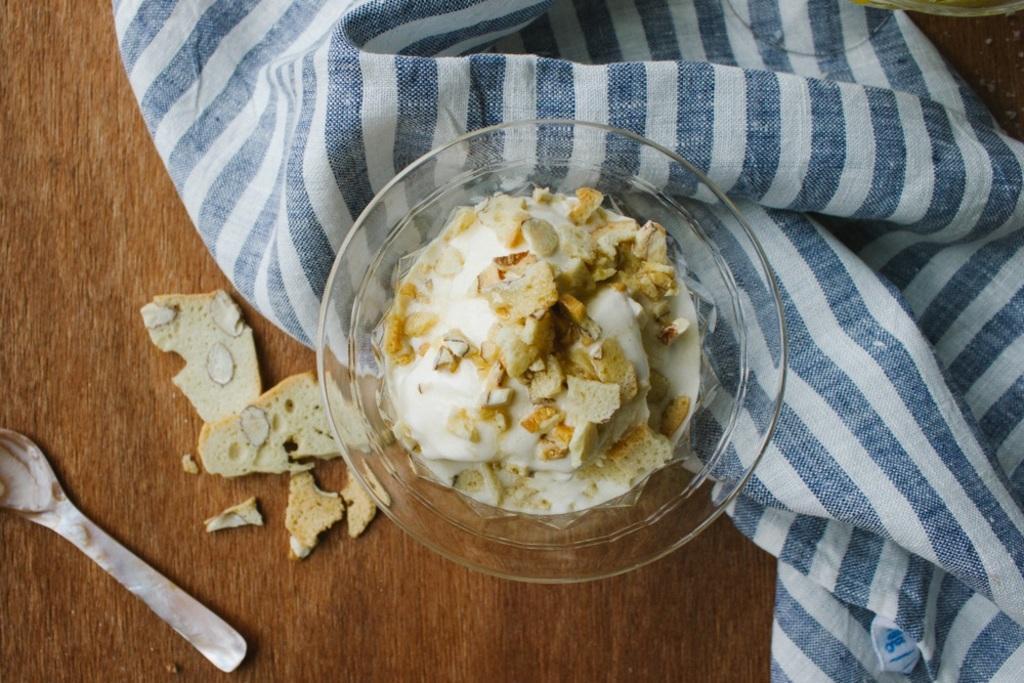Can you describe this image briefly? The food is highlighted in this picture. The food is presented in a bowl. Beside this bowl there is a cloth. This is spoon. 